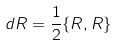Convert formula to latex. <formula><loc_0><loc_0><loc_500><loc_500>d R = \frac { 1 } { 2 } \{ R , R \}</formula> 